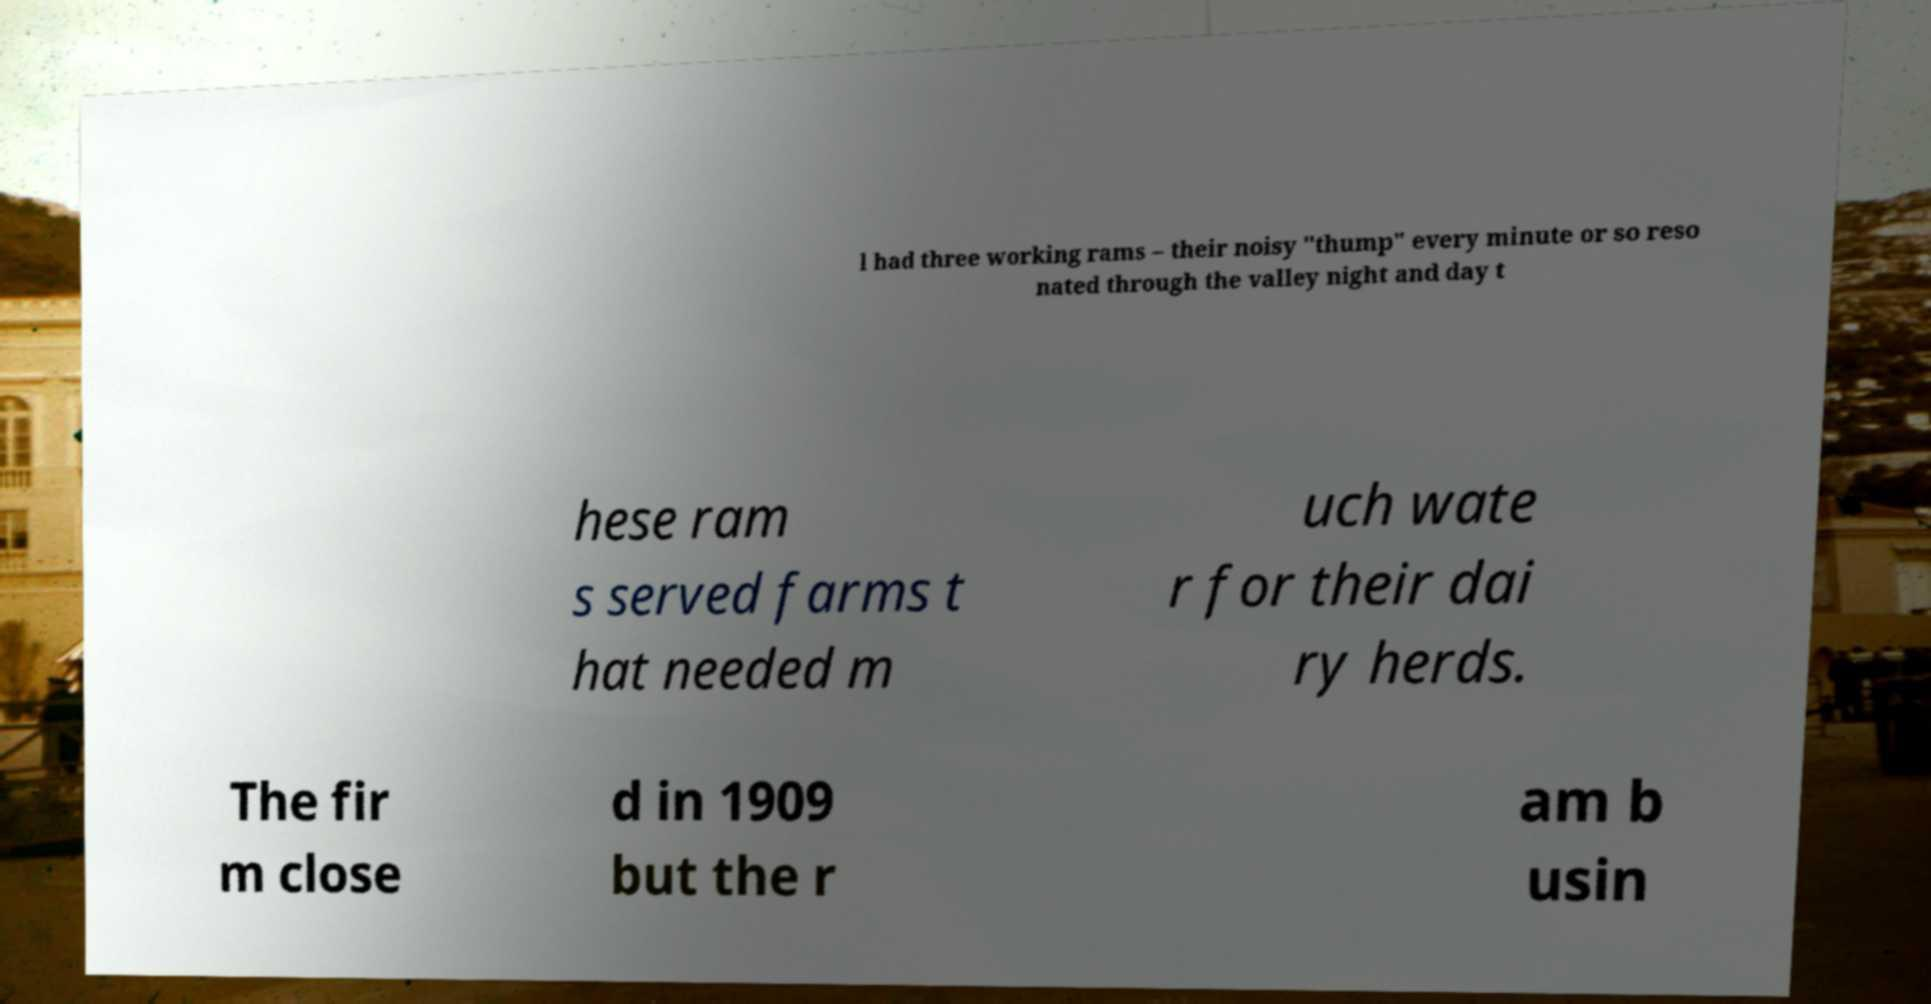Please read and relay the text visible in this image. What does it say? l had three working rams – their noisy "thump" every minute or so reso nated through the valley night and day t hese ram s served farms t hat needed m uch wate r for their dai ry herds. The fir m close d in 1909 but the r am b usin 